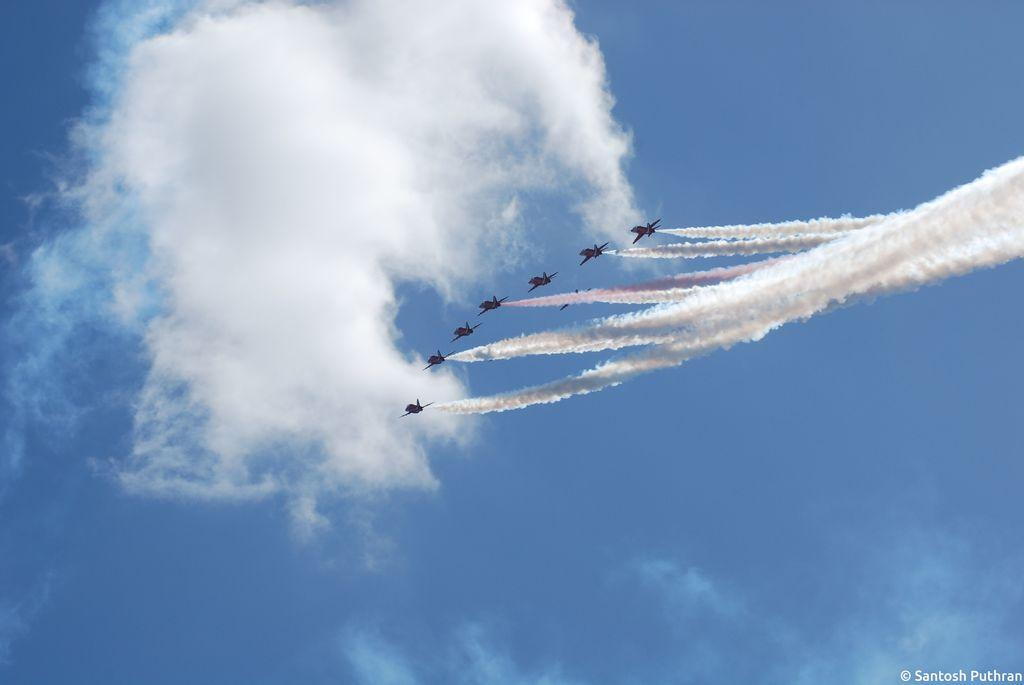What is the main subject of the image? The main subject of the image is an aircraft flying in the sky. What can be seen on the right side of the image? There is smoke visible on the right side of the image. What is present in the background of the image? There are clouds in the sky in the background of the image. How many snails can be seen crawling on the aircraft in the image? There are no snails present in the image; it features an aircraft flying in the sky with smoke visible on the right side and clouds in the background. 